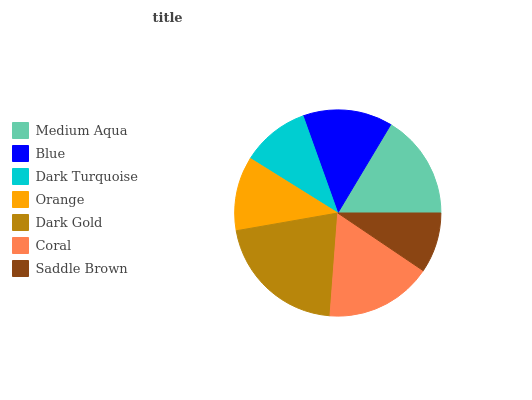Is Saddle Brown the minimum?
Answer yes or no. Yes. Is Dark Gold the maximum?
Answer yes or no. Yes. Is Blue the minimum?
Answer yes or no. No. Is Blue the maximum?
Answer yes or no. No. Is Medium Aqua greater than Blue?
Answer yes or no. Yes. Is Blue less than Medium Aqua?
Answer yes or no. Yes. Is Blue greater than Medium Aqua?
Answer yes or no. No. Is Medium Aqua less than Blue?
Answer yes or no. No. Is Blue the high median?
Answer yes or no. Yes. Is Blue the low median?
Answer yes or no. Yes. Is Orange the high median?
Answer yes or no. No. Is Dark Gold the low median?
Answer yes or no. No. 